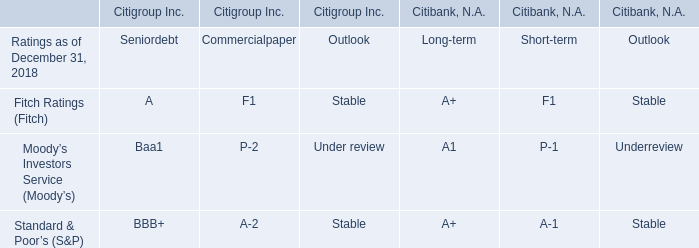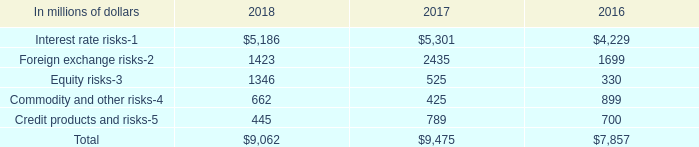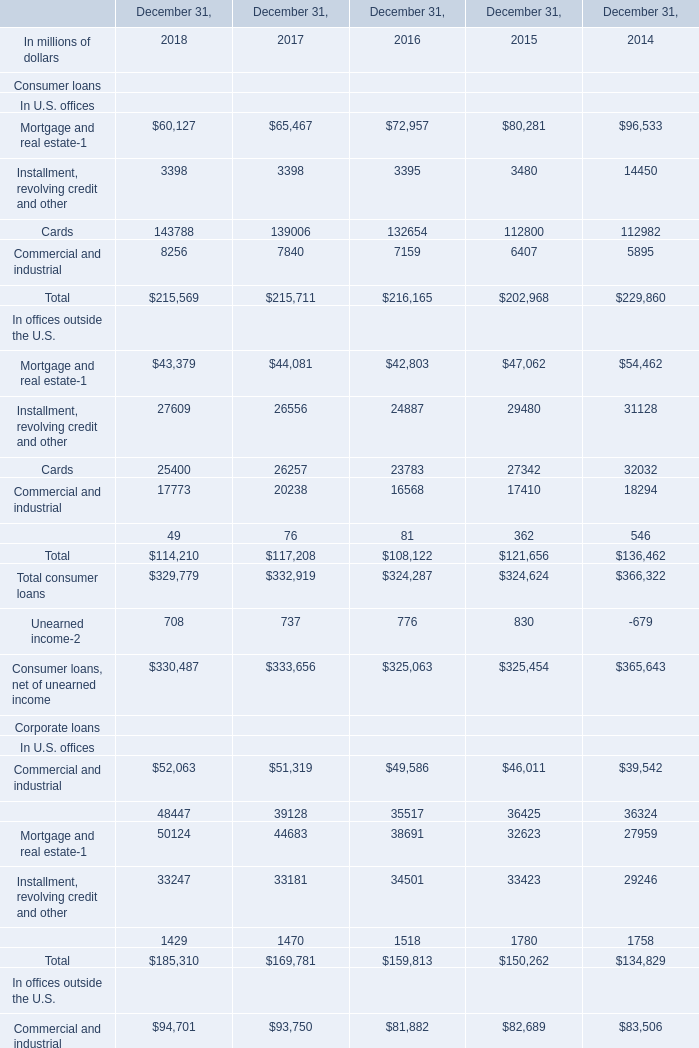what's the total amount of Interest rate risks of 2016, Financial institutions In U.S. offices of December 31, 2014, and Cards of December 31, 2014 ? 
Computations: ((4229.0 + 36324.0) + 112982.0)
Answer: 153535.0. 